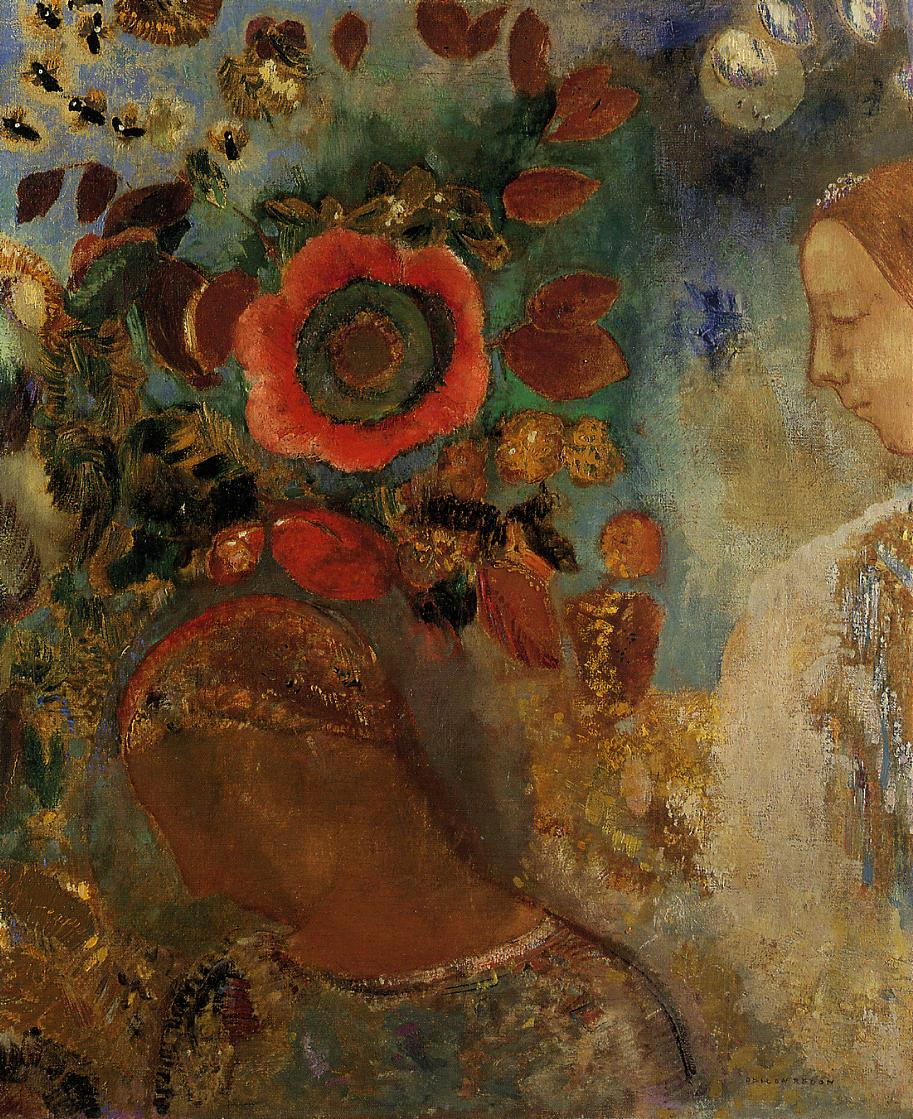What emotions could this painting be trying to convey? The painting seems to evoke a sense of tranquility and oneness with nature. The warm hues and the woman's peaceful expression suggest a theme of harmony, while the vibrant background colors could symbolize vitality and the cyclical bloom of life. It's an artistic exploration that invites the viewer to contemplate the beauty and ephemeral nature of existence. 